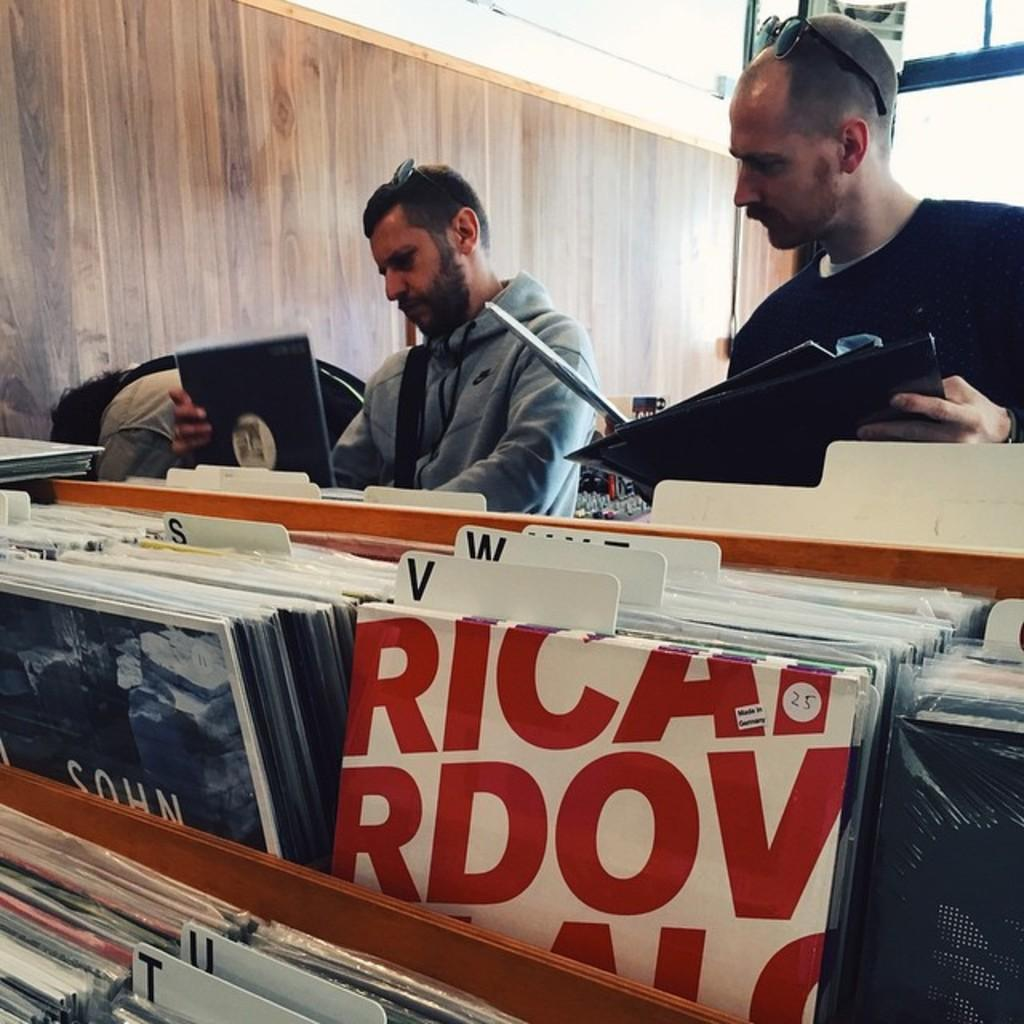How many people are in the image? There are two men in the image. What are the men holding in the image? The men are holding books. Are there any other books visible in the image? Yes, there are books at the bottom of the image. What can be seen at the top of the image? There is a wall at the top of the image. What type of crown is the man wearing in the image? There is no crown present in the image; the men are holding books. How many trees can be seen in the image? There are no trees visible in the image. 